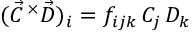<formula> <loc_0><loc_0><loc_500><loc_500>( \vec { C } \, ^ { \times } \vec { D } ) _ { i } = f _ { i j k } \, C _ { j } \, D _ { k }</formula> 